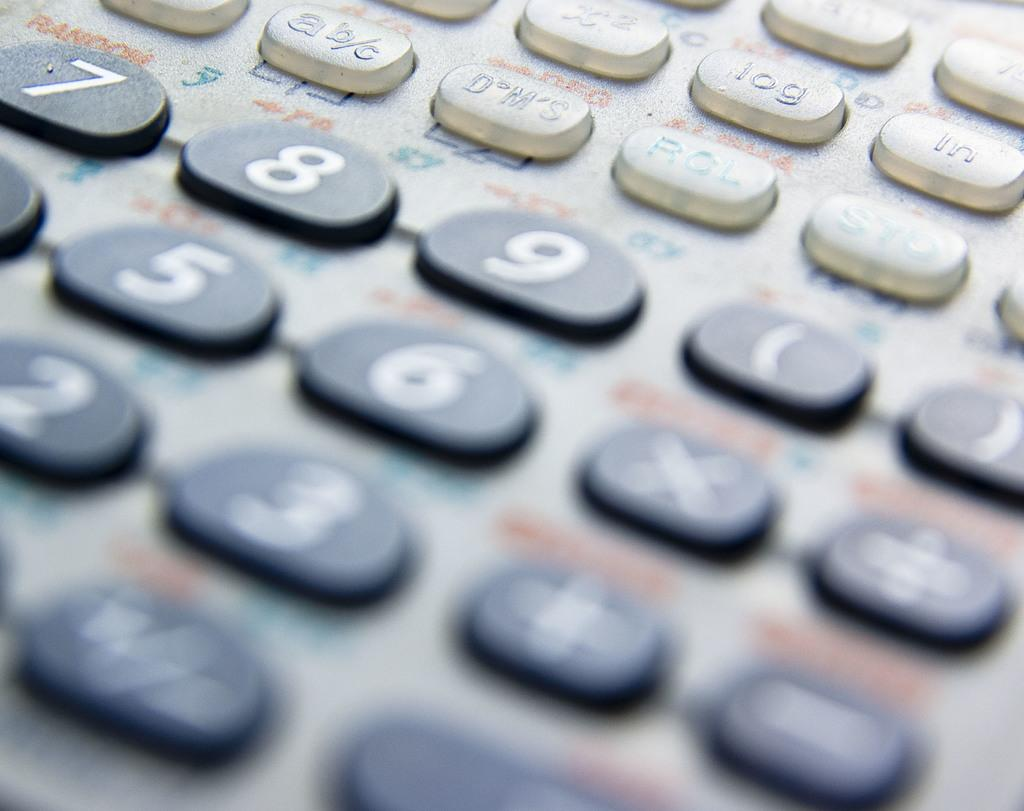<image>
Render a clear and concise summary of the photo. Scientific calculator showing the numerical part along with a Random button. 